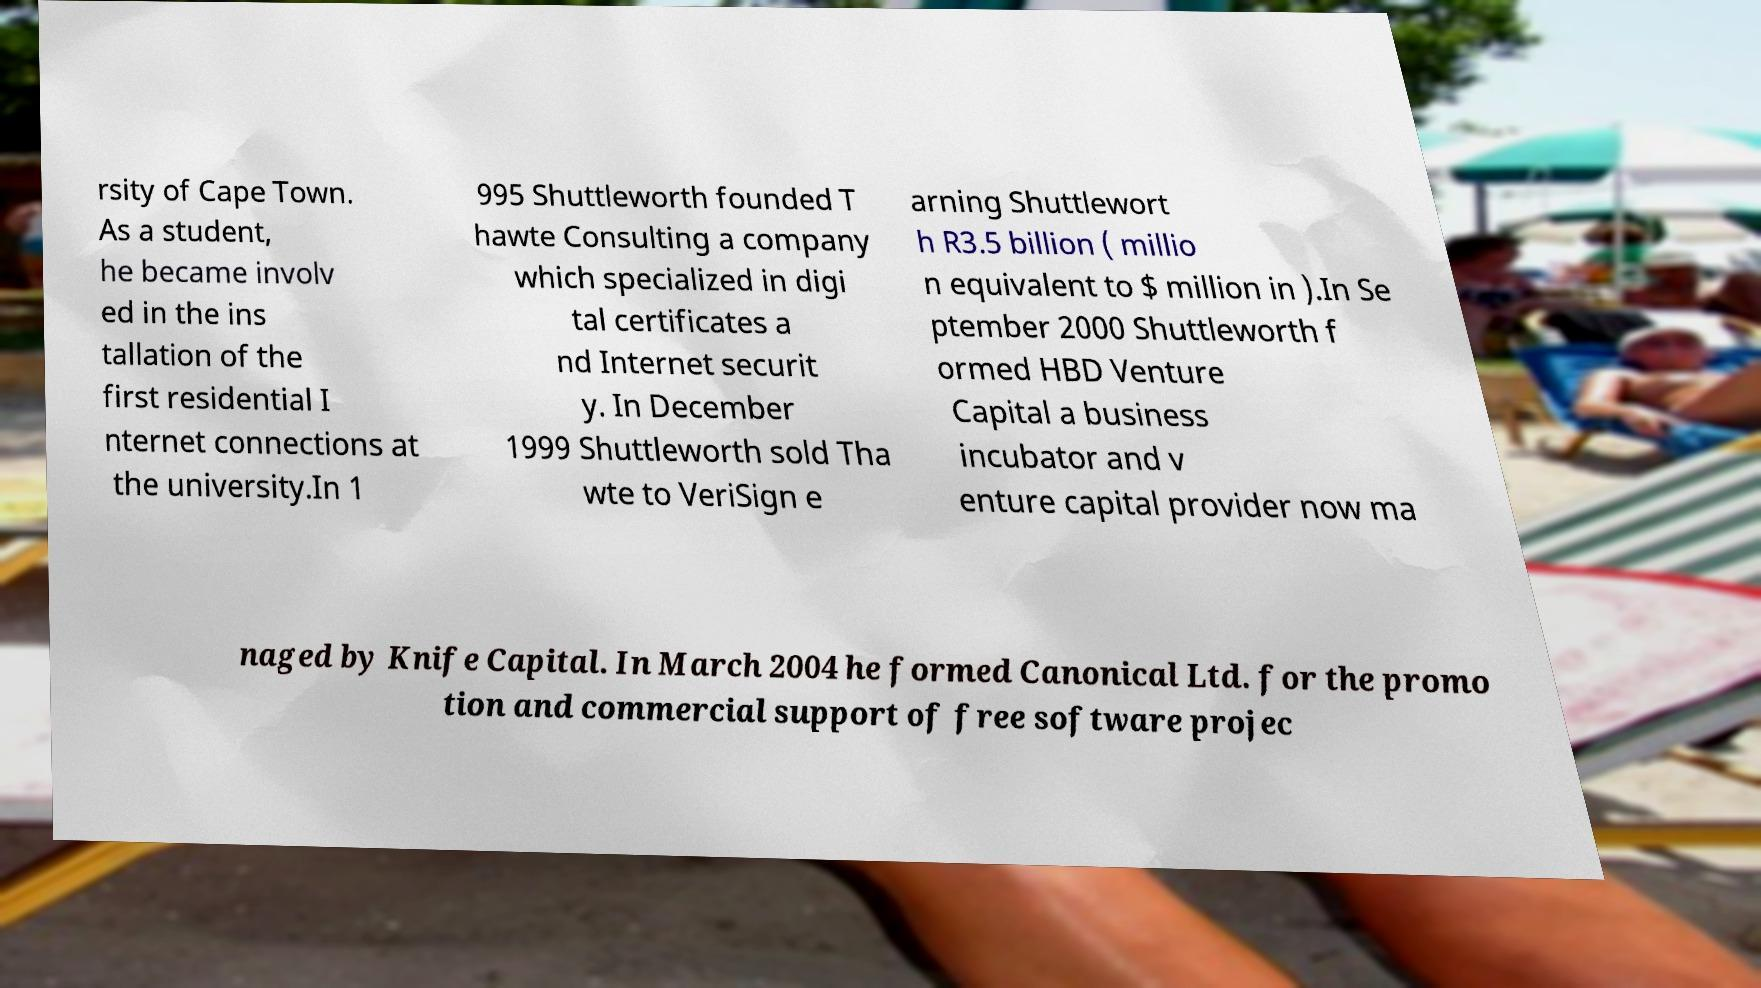Please read and relay the text visible in this image. What does it say? rsity of Cape Town. As a student, he became involv ed in the ins tallation of the first residential I nternet connections at the university.In 1 995 Shuttleworth founded T hawte Consulting a company which specialized in digi tal certificates a nd Internet securit y. In December 1999 Shuttleworth sold Tha wte to VeriSign e arning Shuttlewort h R3.5 billion ( millio n equivalent to $ million in ).In Se ptember 2000 Shuttleworth f ormed HBD Venture Capital a business incubator and v enture capital provider now ma naged by Knife Capital. In March 2004 he formed Canonical Ltd. for the promo tion and commercial support of free software projec 